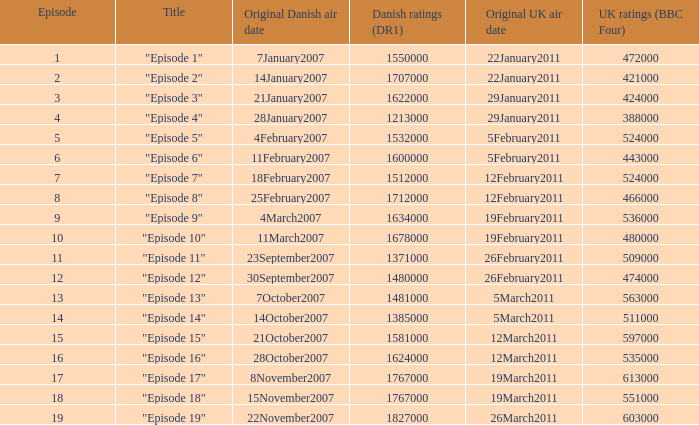What is the original danish broadcast date of "episode 17"? 8November2007. 